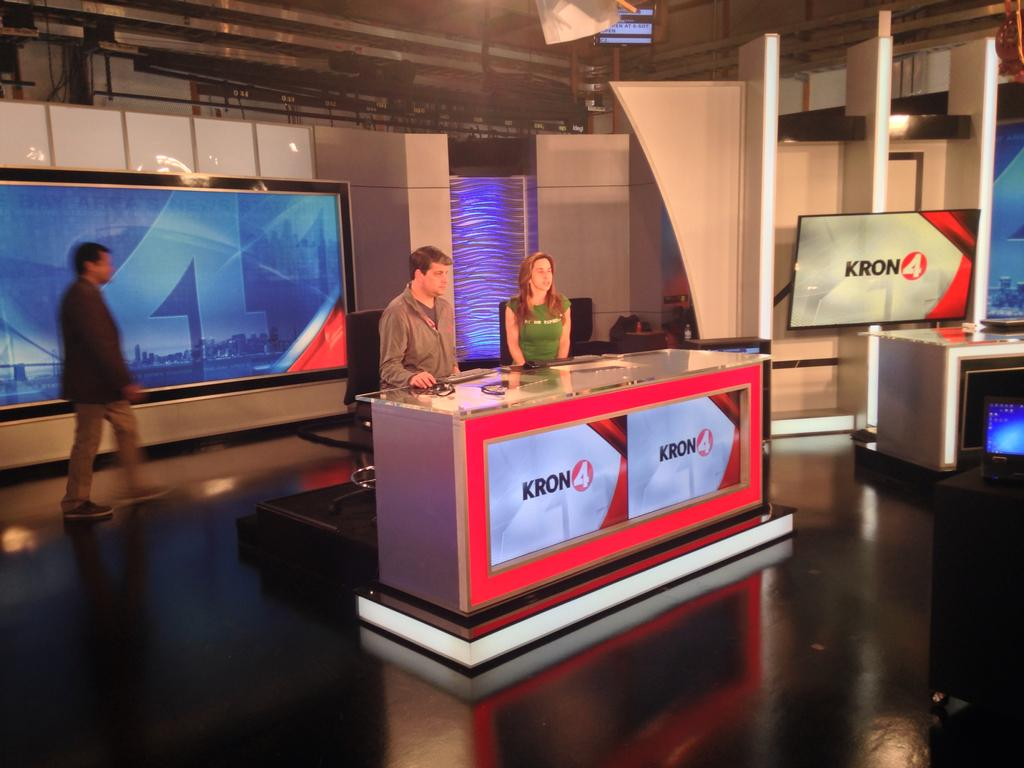<image>
Present a compact description of the photo's key features. a Kron 4 news station with two people talking 